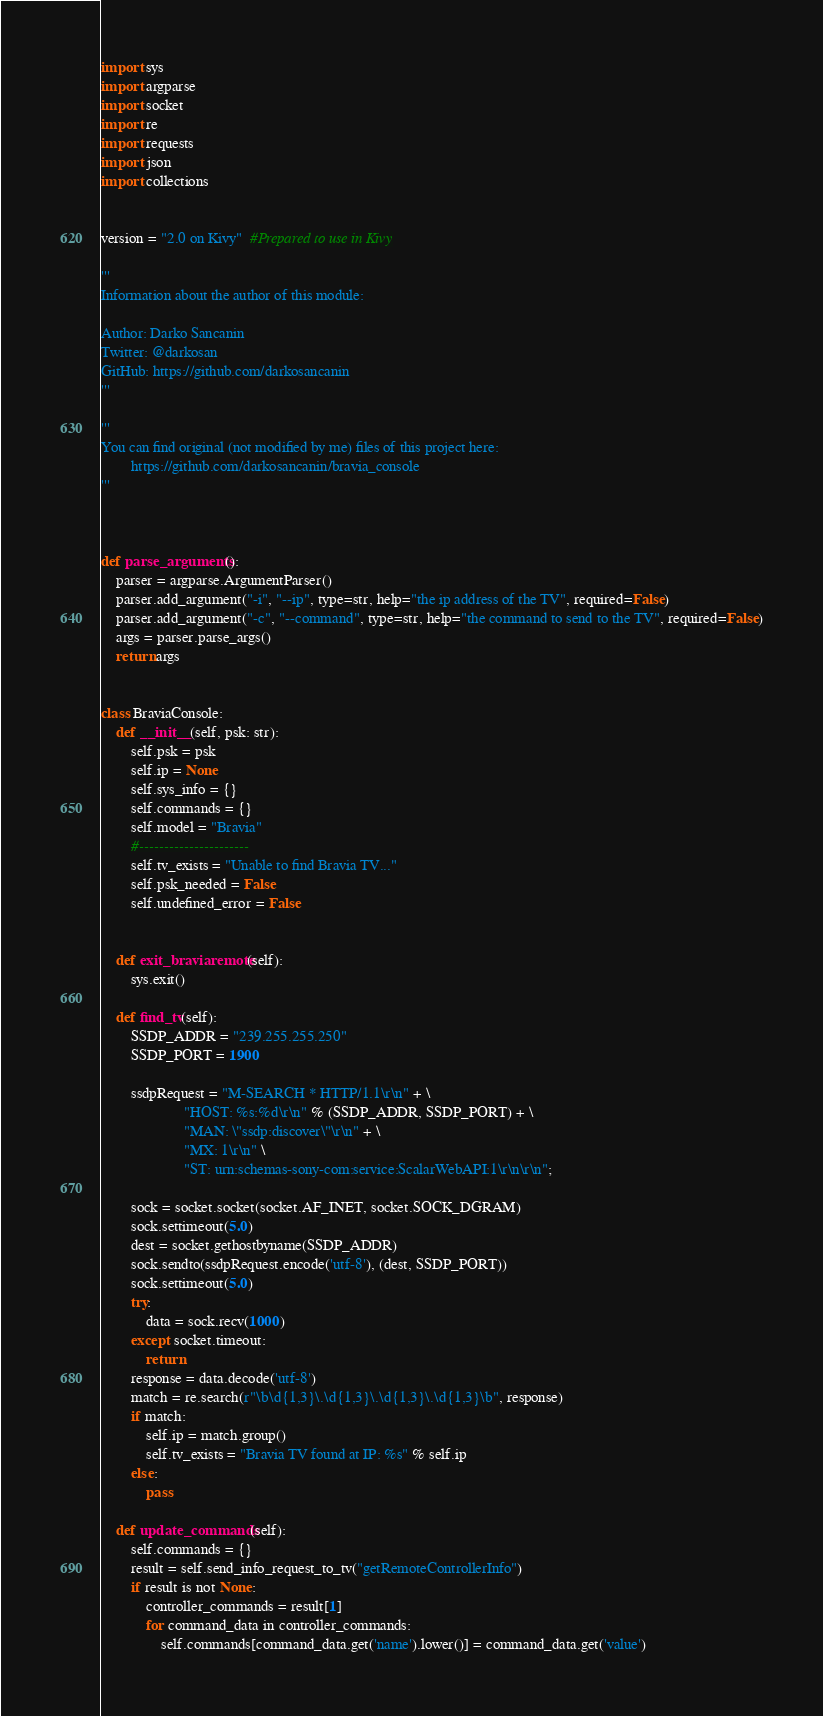<code> <loc_0><loc_0><loc_500><loc_500><_Python_>import sys
import argparse
import socket
import re
import requests
import json
import collections


version = "2.0 on Kivy"  #Prepared to use in Kivy

'''
Information about the author of this module:

Author: Darko Sancanin
Twitter: @darkosan
GitHub: https://github.com/darkosancanin
'''

'''
You can find original (not modified by me) files of this project here:
        https://github.com/darkosancanin/bravia_console
'''



def parse_arguments():
    parser = argparse.ArgumentParser()
    parser.add_argument("-i", "--ip", type=str, help="the ip address of the TV", required=False)
    parser.add_argument("-c", "--command", type=str, help="the command to send to the TV", required=False)
    args = parser.parse_args()
    return args


class BraviaConsole:
    def __init__(self, psk: str):
        self.psk = psk
        self.ip = None
        self.sys_info = {}
        self.commands = {}
        self.model = "Bravia"
        #----------------------
        self.tv_exists = "Unable to find Bravia TV..."
        self.psk_needed = False
        self.undefined_error = False


    def exit_braviaremote(self):
        sys.exit()

    def find_tv(self):
        SSDP_ADDR = "239.255.255.250"
        SSDP_PORT = 1900

        ssdpRequest = "M-SEARCH * HTTP/1.1\r\n" + \
                      "HOST: %s:%d\r\n" % (SSDP_ADDR, SSDP_PORT) + \
                      "MAN: \"ssdp:discover\"\r\n" + \
                      "MX: 1\r\n" \
                      "ST: urn:schemas-sony-com:service:ScalarWebAPI:1\r\n\r\n";

        sock = socket.socket(socket.AF_INET, socket.SOCK_DGRAM)
        sock.settimeout(5.0)
        dest = socket.gethostbyname(SSDP_ADDR)
        sock.sendto(ssdpRequest.encode('utf-8'), (dest, SSDP_PORT))
        sock.settimeout(5.0)
        try:
            data = sock.recv(1000)
        except socket.timeout:
            return
        response = data.decode('utf-8')
        match = re.search(r"\b\d{1,3}\.\d{1,3}\.\d{1,3}\.\d{1,3}\b", response)
        if match:
            self.ip = match.group()
            self.tv_exists = "Bravia TV found at IP: %s" % self.ip
        else:
            pass

    def update_commands(self):
        self.commands = {}
        result = self.send_info_request_to_tv("getRemoteControllerInfo")
        if result is not None:
            controller_commands = result[1]
            for command_data in controller_commands:
                self.commands[command_data.get('name').lower()] = command_data.get('value')</code> 